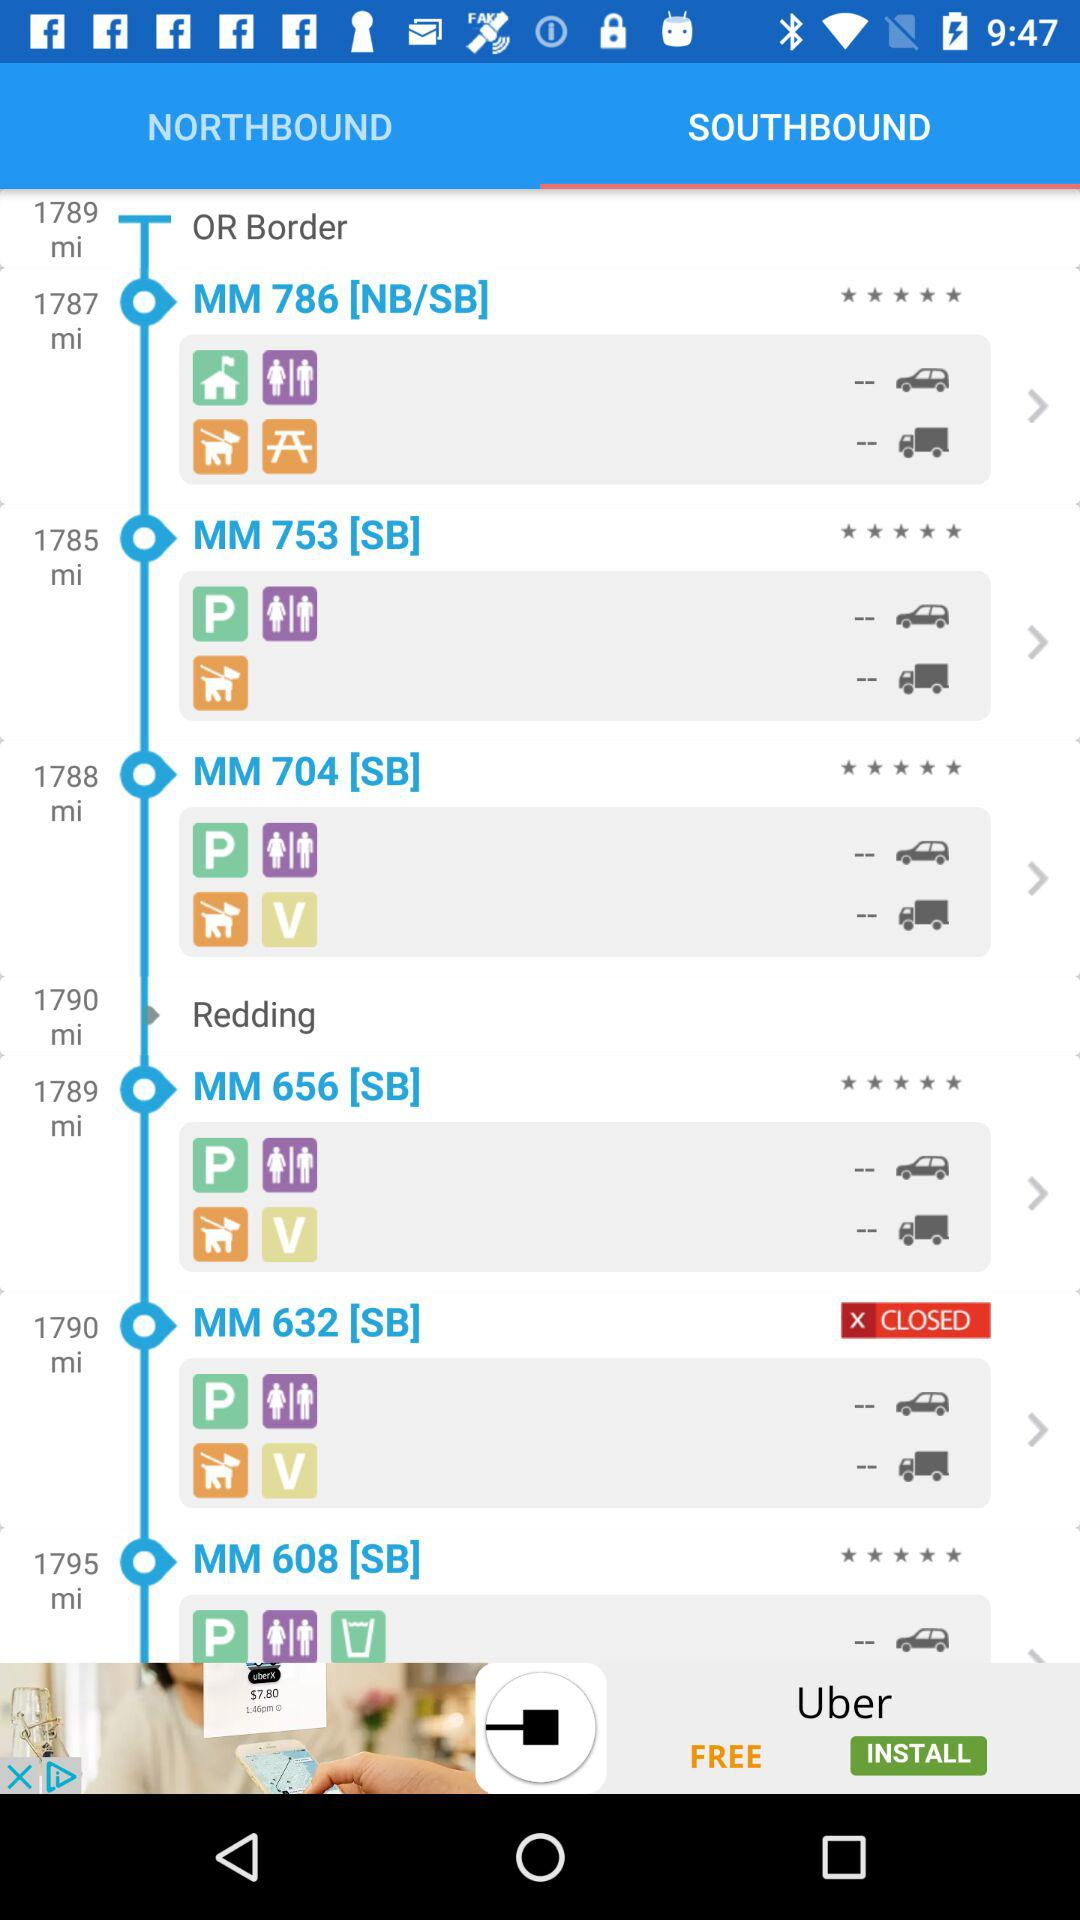What is the distance for MM786 (NB/SB)? The distance is 1787 miles. 